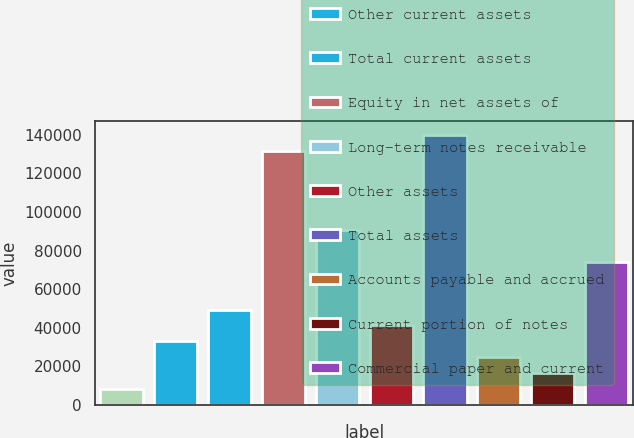<chart> <loc_0><loc_0><loc_500><loc_500><bar_chart><fcel>Cash and cash equivalents<fcel>Other current assets<fcel>Total current assets<fcel>Equity in net assets of<fcel>Long-term notes receivable<fcel>Other assets<fcel>Total assets<fcel>Accounts payable and accrued<fcel>Current portion of notes<fcel>Commercial paper and current<nl><fcel>8237.2<fcel>32918.8<fcel>49373.2<fcel>131645<fcel>90509.2<fcel>41146<fcel>139872<fcel>24691.6<fcel>16464.4<fcel>74054.8<nl></chart> 